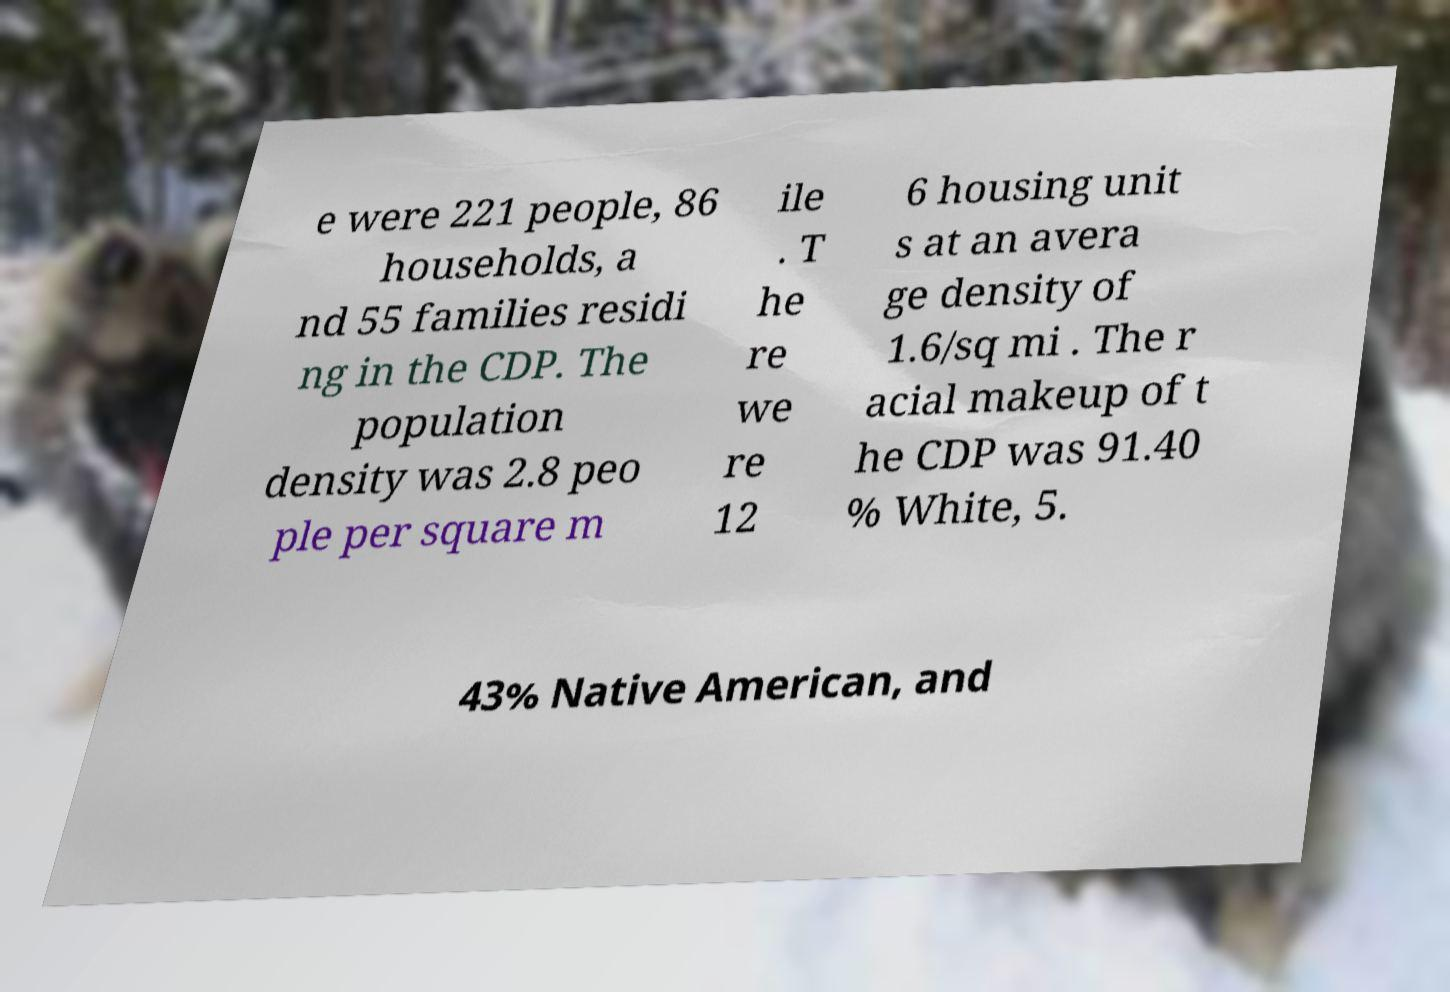I need the written content from this picture converted into text. Can you do that? e were 221 people, 86 households, a nd 55 families residi ng in the CDP. The population density was 2.8 peo ple per square m ile . T he re we re 12 6 housing unit s at an avera ge density of 1.6/sq mi . The r acial makeup of t he CDP was 91.40 % White, 5. 43% Native American, and 